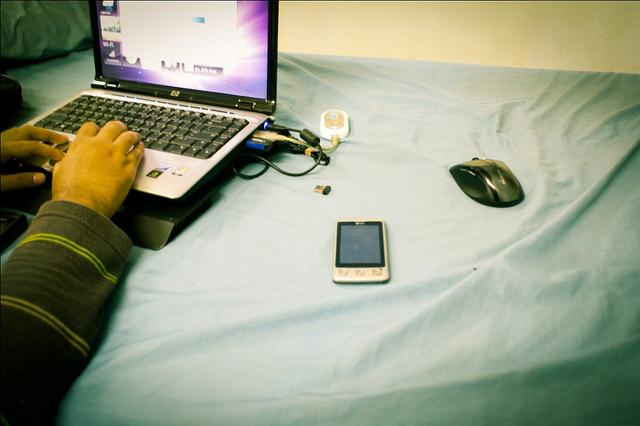What color is the wallpaper on the laptop background?
Be succinct. Purple. Are the lines on the shirt parallel?
Answer briefly. Yes. What is on the bed?
Keep it brief. Phone, mouse, laptop. 